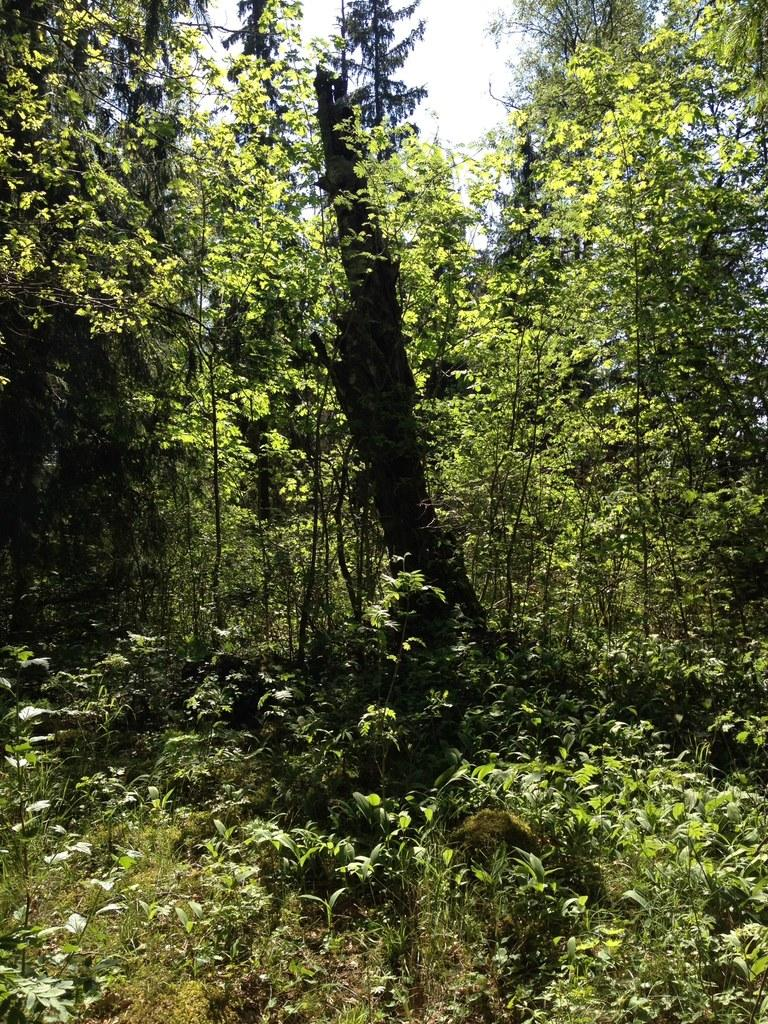What type of vegetation can be seen in the image? There are plants in the image. What is on the ground in the image? There is grass on the ground in the image. What can be seen in the background of the image? There are trees in the background of the image. What is visible in the sky in the image? There are clouds in the sky, and the sky is blue. Can you see any zebras grazing on the rice in the image? There are no zebras or rice present in the image. What type of agreement is being signed by the plants in the image? There is no agreement being signed in the image, as it features plants, grass, trees, clouds, and a blue sky. 